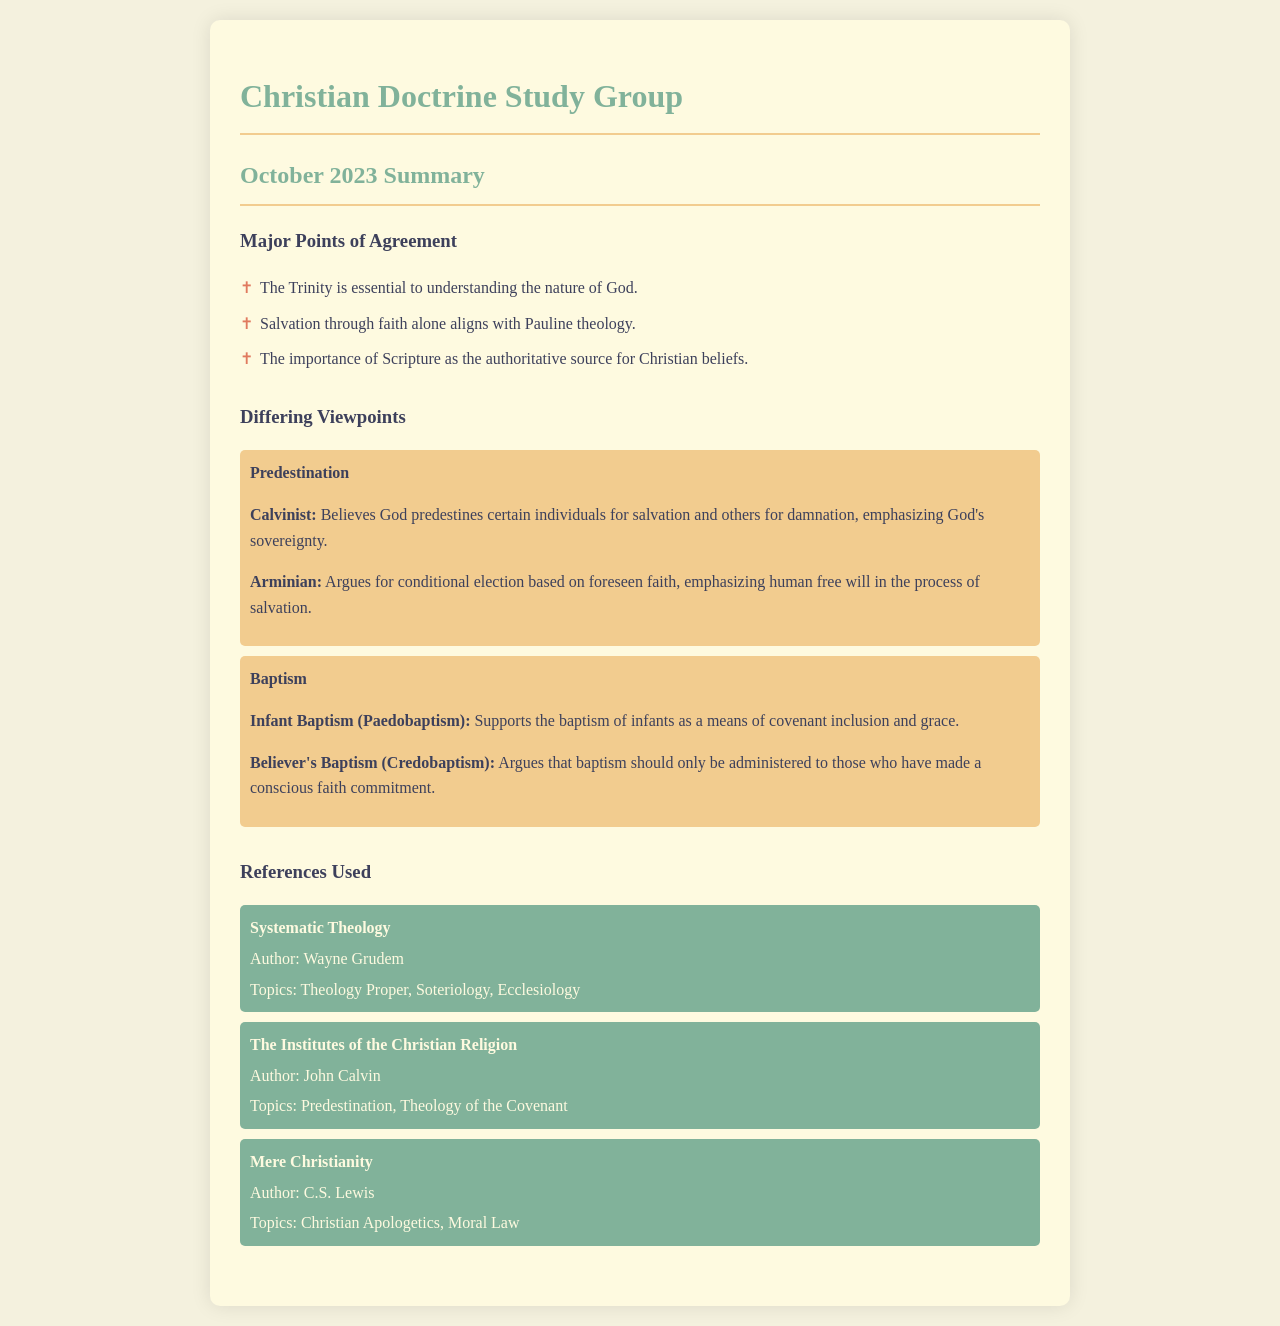What are the key theological concepts agreed upon? The major points of agreement are listed in the document under "Major Points of Agreement."
Answer: The Trinity, Salvation through faith alone, Importance of Scripture What is a major differing viewpoint on baptism? The document details differing viewpoints on baptism, specifically highlighting two perspectives.
Answer: Infant Baptism and Believer's Baptism Who is the author of "Systematic Theology"? The document provides authors for the references used, indicating the author for this particular text.
Answer: Wayne Grudem What are the topics covered in "Mere Christianity"? The document states the topics addressed in this reference, which are categorized under the author.
Answer: Christian Apologetics, Moral Law What theological stance does the Calvinist viewpoint on predestination emphasize? The document explains what the Calvinist perspective believes regarding predestination.
Answer: God's sovereignty What is the stance of the Arminian viewpoint on predestination? The document elaborates on the Arminian viewpoint regarding the basis for salvation.
Answer: Conditional election based on foreseen faith How many major points of agreement are listed in the document? The document lists three major points, and counting them provides the answer.
Answer: Three What book discusses the theology of the covenant? The document indicates which reference addresses this specific theological concept.
Answer: The Institutes of the Christian Religion 